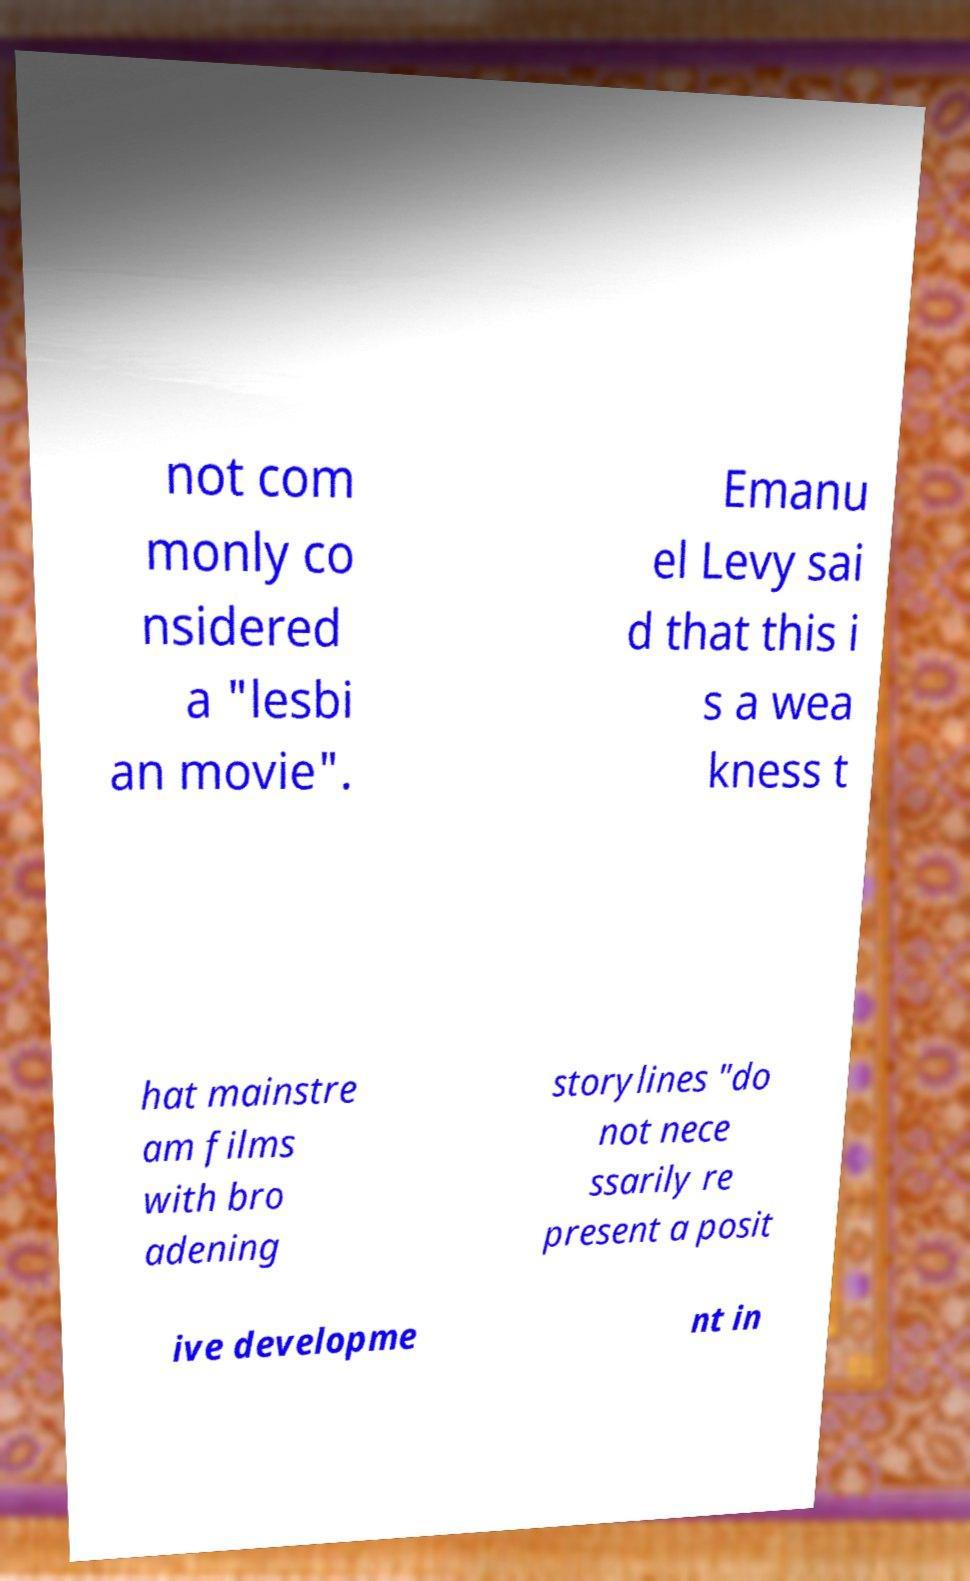What messages or text are displayed in this image? I need them in a readable, typed format. not com monly co nsidered a "lesbi an movie". Emanu el Levy sai d that this i s a wea kness t hat mainstre am films with bro adening storylines "do not nece ssarily re present a posit ive developme nt in 